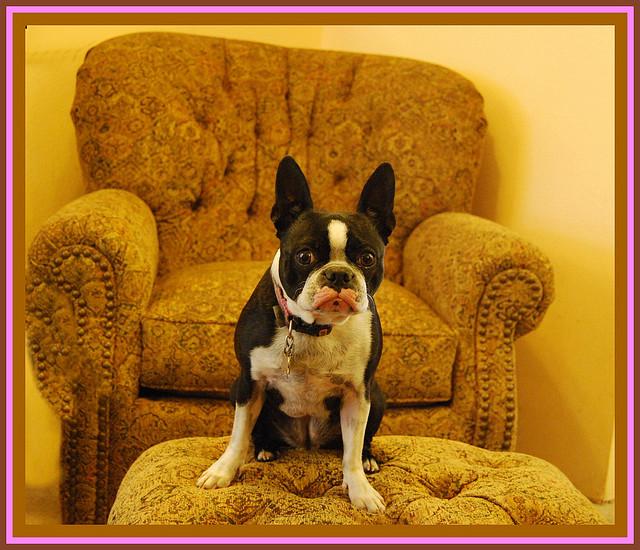Is this dog sleeping?
Concise answer only. No. What is the dog sitting on?
Keep it brief. Ottoman. How old is this dog?
Give a very brief answer. 5. 